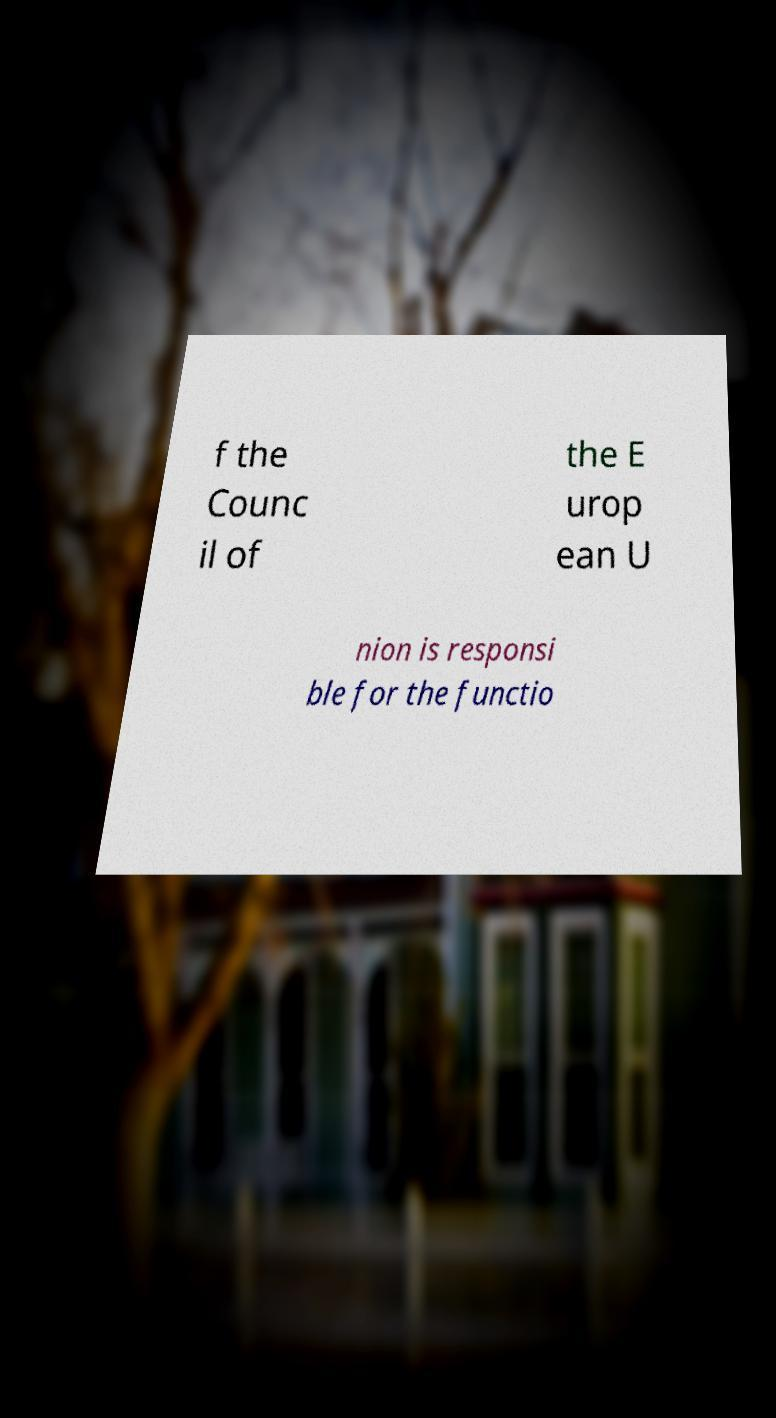Please read and relay the text visible in this image. What does it say? f the Counc il of the E urop ean U nion is responsi ble for the functio 